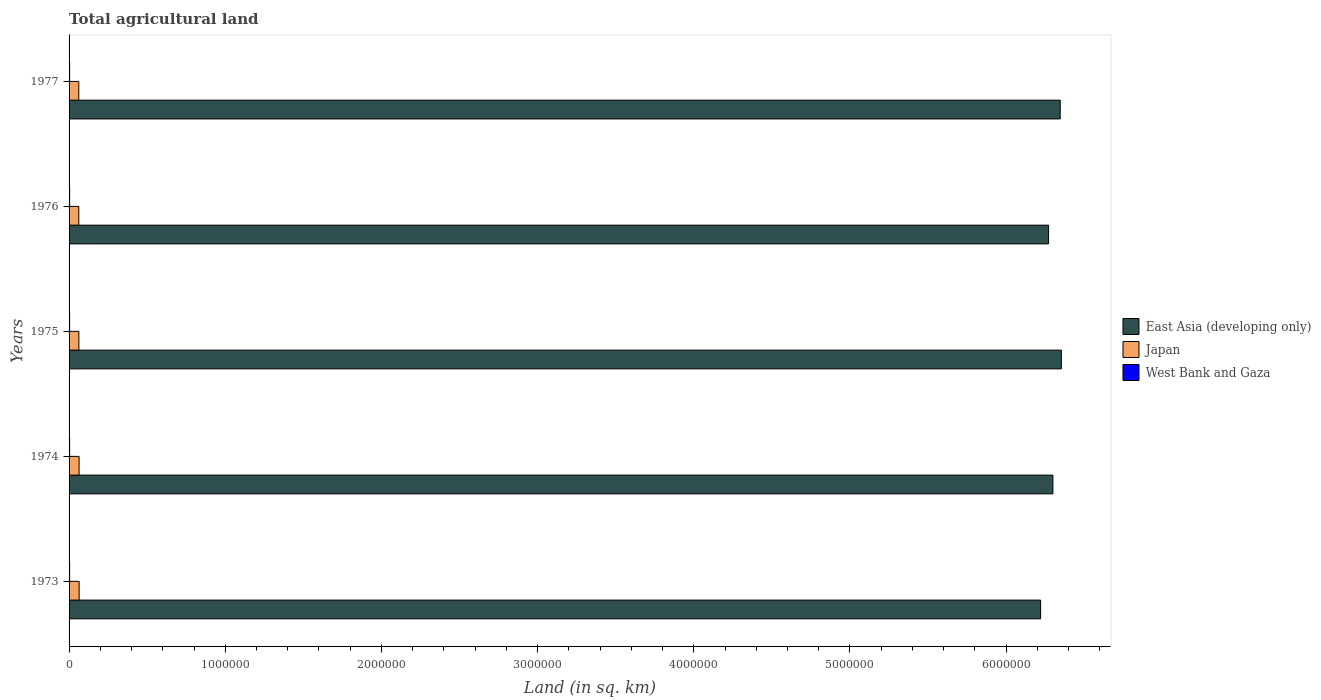How many different coloured bars are there?
Ensure brevity in your answer.  3. Are the number of bars on each tick of the Y-axis equal?
Ensure brevity in your answer.  Yes. How many bars are there on the 3rd tick from the top?
Provide a short and direct response. 3. In how many cases, is the number of bars for a given year not equal to the number of legend labels?
Keep it short and to the point. 0. What is the total agricultural land in East Asia (developing only) in 1977?
Make the answer very short. 6.35e+06. Across all years, what is the maximum total agricultural land in East Asia (developing only)?
Your answer should be very brief. 6.35e+06. Across all years, what is the minimum total agricultural land in West Bank and Gaza?
Your answer should be compact. 3680. In which year was the total agricultural land in East Asia (developing only) maximum?
Keep it short and to the point. 1975. In which year was the total agricultural land in East Asia (developing only) minimum?
Keep it short and to the point. 1973. What is the total total agricultural land in West Bank and Gaza in the graph?
Give a very brief answer. 1.85e+04. What is the difference between the total agricultural land in East Asia (developing only) in 1974 and that in 1976?
Ensure brevity in your answer.  2.77e+04. What is the difference between the total agricultural land in West Bank and Gaza in 1977 and the total agricultural land in East Asia (developing only) in 1973?
Give a very brief answer. -6.22e+06. What is the average total agricultural land in West Bank and Gaza per year?
Your answer should be very brief. 3700. In the year 1977, what is the difference between the total agricultural land in Japan and total agricultural land in West Bank and Gaza?
Offer a very short reply. 5.84e+04. In how many years, is the total agricultural land in West Bank and Gaza greater than 5400000 sq.km?
Provide a short and direct response. 0. Is the total agricultural land in West Bank and Gaza in 1973 less than that in 1976?
Ensure brevity in your answer.  Yes. What is the difference between the highest and the second highest total agricultural land in East Asia (developing only)?
Your answer should be compact. 7300. What is the difference between the highest and the lowest total agricultural land in East Asia (developing only)?
Offer a terse response. 1.33e+05. In how many years, is the total agricultural land in Japan greater than the average total agricultural land in Japan taken over all years?
Ensure brevity in your answer.  2. Is the sum of the total agricultural land in West Bank and Gaza in 1973 and 1975 greater than the maximum total agricultural land in East Asia (developing only) across all years?
Offer a very short reply. No. What does the 3rd bar from the top in 1977 represents?
Provide a short and direct response. East Asia (developing only). What does the 1st bar from the bottom in 1977 represents?
Offer a very short reply. East Asia (developing only). Is it the case that in every year, the sum of the total agricultural land in Japan and total agricultural land in West Bank and Gaza is greater than the total agricultural land in East Asia (developing only)?
Make the answer very short. No. How many bars are there?
Make the answer very short. 15. Are all the bars in the graph horizontal?
Make the answer very short. Yes. How many years are there in the graph?
Offer a very short reply. 5. Where does the legend appear in the graph?
Provide a succinct answer. Center right. What is the title of the graph?
Keep it short and to the point. Total agricultural land. What is the label or title of the X-axis?
Make the answer very short. Land (in sq. km). What is the Land (in sq. km) in East Asia (developing only) in 1973?
Make the answer very short. 6.22e+06. What is the Land (in sq. km) of Japan in 1973?
Provide a short and direct response. 6.45e+04. What is the Land (in sq. km) of West Bank and Gaza in 1973?
Keep it short and to the point. 3680. What is the Land (in sq. km) in East Asia (developing only) in 1974?
Your response must be concise. 6.30e+06. What is the Land (in sq. km) in Japan in 1974?
Ensure brevity in your answer.  6.42e+04. What is the Land (in sq. km) of West Bank and Gaza in 1974?
Your answer should be very brief. 3690. What is the Land (in sq. km) of East Asia (developing only) in 1975?
Your answer should be very brief. 6.35e+06. What is the Land (in sq. km) of Japan in 1975?
Your response must be concise. 6.27e+04. What is the Land (in sq. km) in West Bank and Gaza in 1975?
Provide a short and direct response. 3690. What is the Land (in sq. km) of East Asia (developing only) in 1976?
Your answer should be very brief. 6.27e+06. What is the Land (in sq. km) in Japan in 1976?
Offer a terse response. 6.24e+04. What is the Land (in sq. km) of West Bank and Gaza in 1976?
Give a very brief answer. 3710. What is the Land (in sq. km) in East Asia (developing only) in 1977?
Your response must be concise. 6.35e+06. What is the Land (in sq. km) in Japan in 1977?
Give a very brief answer. 6.22e+04. What is the Land (in sq. km) of West Bank and Gaza in 1977?
Keep it short and to the point. 3730. Across all years, what is the maximum Land (in sq. km) of East Asia (developing only)?
Your answer should be very brief. 6.35e+06. Across all years, what is the maximum Land (in sq. km) in Japan?
Provide a short and direct response. 6.45e+04. Across all years, what is the maximum Land (in sq. km) in West Bank and Gaza?
Your response must be concise. 3730. Across all years, what is the minimum Land (in sq. km) in East Asia (developing only)?
Your answer should be very brief. 6.22e+06. Across all years, what is the minimum Land (in sq. km) in Japan?
Your answer should be compact. 6.22e+04. Across all years, what is the minimum Land (in sq. km) in West Bank and Gaza?
Make the answer very short. 3680. What is the total Land (in sq. km) in East Asia (developing only) in the graph?
Provide a succinct answer. 3.15e+07. What is the total Land (in sq. km) in Japan in the graph?
Provide a short and direct response. 3.16e+05. What is the total Land (in sq. km) of West Bank and Gaza in the graph?
Your answer should be very brief. 1.85e+04. What is the difference between the Land (in sq. km) in East Asia (developing only) in 1973 and that in 1974?
Provide a succinct answer. -7.87e+04. What is the difference between the Land (in sq. km) of Japan in 1973 and that in 1974?
Your answer should be very brief. 320. What is the difference between the Land (in sq. km) of West Bank and Gaza in 1973 and that in 1974?
Ensure brevity in your answer.  -10. What is the difference between the Land (in sq. km) of East Asia (developing only) in 1973 and that in 1975?
Keep it short and to the point. -1.33e+05. What is the difference between the Land (in sq. km) of Japan in 1973 and that in 1975?
Ensure brevity in your answer.  1740. What is the difference between the Land (in sq. km) in West Bank and Gaza in 1973 and that in 1975?
Your response must be concise. -10. What is the difference between the Land (in sq. km) in East Asia (developing only) in 1973 and that in 1976?
Ensure brevity in your answer.  -5.10e+04. What is the difference between the Land (in sq. km) in Japan in 1973 and that in 1976?
Your answer should be compact. 2110. What is the difference between the Land (in sq. km) of East Asia (developing only) in 1973 and that in 1977?
Keep it short and to the point. -1.26e+05. What is the difference between the Land (in sq. km) of Japan in 1973 and that in 1977?
Offer a terse response. 2320. What is the difference between the Land (in sq. km) in East Asia (developing only) in 1974 and that in 1975?
Offer a terse response. -5.41e+04. What is the difference between the Land (in sq. km) of Japan in 1974 and that in 1975?
Your answer should be very brief. 1420. What is the difference between the Land (in sq. km) of East Asia (developing only) in 1974 and that in 1976?
Your response must be concise. 2.77e+04. What is the difference between the Land (in sq. km) of Japan in 1974 and that in 1976?
Offer a terse response. 1790. What is the difference between the Land (in sq. km) in West Bank and Gaza in 1974 and that in 1976?
Provide a short and direct response. -20. What is the difference between the Land (in sq. km) in East Asia (developing only) in 1974 and that in 1977?
Your answer should be very brief. -4.68e+04. What is the difference between the Land (in sq. km) of East Asia (developing only) in 1975 and that in 1976?
Provide a short and direct response. 8.18e+04. What is the difference between the Land (in sq. km) in Japan in 1975 and that in 1976?
Offer a very short reply. 370. What is the difference between the Land (in sq. km) in East Asia (developing only) in 1975 and that in 1977?
Offer a terse response. 7300. What is the difference between the Land (in sq. km) of Japan in 1975 and that in 1977?
Provide a succinct answer. 580. What is the difference between the Land (in sq. km) in West Bank and Gaza in 1975 and that in 1977?
Make the answer very short. -40. What is the difference between the Land (in sq. km) in East Asia (developing only) in 1976 and that in 1977?
Your answer should be compact. -7.45e+04. What is the difference between the Land (in sq. km) in Japan in 1976 and that in 1977?
Your response must be concise. 210. What is the difference between the Land (in sq. km) in East Asia (developing only) in 1973 and the Land (in sq. km) in Japan in 1974?
Make the answer very short. 6.16e+06. What is the difference between the Land (in sq. km) in East Asia (developing only) in 1973 and the Land (in sq. km) in West Bank and Gaza in 1974?
Offer a terse response. 6.22e+06. What is the difference between the Land (in sq. km) of Japan in 1973 and the Land (in sq. km) of West Bank and Gaza in 1974?
Your answer should be very brief. 6.08e+04. What is the difference between the Land (in sq. km) in East Asia (developing only) in 1973 and the Land (in sq. km) in Japan in 1975?
Provide a succinct answer. 6.16e+06. What is the difference between the Land (in sq. km) in East Asia (developing only) in 1973 and the Land (in sq. km) in West Bank and Gaza in 1975?
Your answer should be very brief. 6.22e+06. What is the difference between the Land (in sq. km) in Japan in 1973 and the Land (in sq. km) in West Bank and Gaza in 1975?
Provide a succinct answer. 6.08e+04. What is the difference between the Land (in sq. km) in East Asia (developing only) in 1973 and the Land (in sq. km) in Japan in 1976?
Give a very brief answer. 6.16e+06. What is the difference between the Land (in sq. km) in East Asia (developing only) in 1973 and the Land (in sq. km) in West Bank and Gaza in 1976?
Give a very brief answer. 6.22e+06. What is the difference between the Land (in sq. km) in Japan in 1973 and the Land (in sq. km) in West Bank and Gaza in 1976?
Give a very brief answer. 6.08e+04. What is the difference between the Land (in sq. km) of East Asia (developing only) in 1973 and the Land (in sq. km) of Japan in 1977?
Your answer should be compact. 6.16e+06. What is the difference between the Land (in sq. km) of East Asia (developing only) in 1973 and the Land (in sq. km) of West Bank and Gaza in 1977?
Ensure brevity in your answer.  6.22e+06. What is the difference between the Land (in sq. km) in Japan in 1973 and the Land (in sq. km) in West Bank and Gaza in 1977?
Your response must be concise. 6.07e+04. What is the difference between the Land (in sq. km) of East Asia (developing only) in 1974 and the Land (in sq. km) of Japan in 1975?
Ensure brevity in your answer.  6.24e+06. What is the difference between the Land (in sq. km) of East Asia (developing only) in 1974 and the Land (in sq. km) of West Bank and Gaza in 1975?
Your response must be concise. 6.30e+06. What is the difference between the Land (in sq. km) of Japan in 1974 and the Land (in sq. km) of West Bank and Gaza in 1975?
Your answer should be very brief. 6.05e+04. What is the difference between the Land (in sq. km) of East Asia (developing only) in 1974 and the Land (in sq. km) of Japan in 1976?
Provide a short and direct response. 6.24e+06. What is the difference between the Land (in sq. km) of East Asia (developing only) in 1974 and the Land (in sq. km) of West Bank and Gaza in 1976?
Your response must be concise. 6.30e+06. What is the difference between the Land (in sq. km) of Japan in 1974 and the Land (in sq. km) of West Bank and Gaza in 1976?
Provide a short and direct response. 6.04e+04. What is the difference between the Land (in sq. km) of East Asia (developing only) in 1974 and the Land (in sq. km) of Japan in 1977?
Offer a terse response. 6.24e+06. What is the difference between the Land (in sq. km) in East Asia (developing only) in 1974 and the Land (in sq. km) in West Bank and Gaza in 1977?
Keep it short and to the point. 6.30e+06. What is the difference between the Land (in sq. km) of Japan in 1974 and the Land (in sq. km) of West Bank and Gaza in 1977?
Provide a short and direct response. 6.04e+04. What is the difference between the Land (in sq. km) of East Asia (developing only) in 1975 and the Land (in sq. km) of Japan in 1976?
Your answer should be very brief. 6.29e+06. What is the difference between the Land (in sq. km) of East Asia (developing only) in 1975 and the Land (in sq. km) of West Bank and Gaza in 1976?
Give a very brief answer. 6.35e+06. What is the difference between the Land (in sq. km) of Japan in 1975 and the Land (in sq. km) of West Bank and Gaza in 1976?
Your response must be concise. 5.90e+04. What is the difference between the Land (in sq. km) of East Asia (developing only) in 1975 and the Land (in sq. km) of Japan in 1977?
Provide a short and direct response. 6.29e+06. What is the difference between the Land (in sq. km) of East Asia (developing only) in 1975 and the Land (in sq. km) of West Bank and Gaza in 1977?
Provide a short and direct response. 6.35e+06. What is the difference between the Land (in sq. km) of Japan in 1975 and the Land (in sq. km) of West Bank and Gaza in 1977?
Ensure brevity in your answer.  5.90e+04. What is the difference between the Land (in sq. km) of East Asia (developing only) in 1976 and the Land (in sq. km) of Japan in 1977?
Offer a very short reply. 6.21e+06. What is the difference between the Land (in sq. km) of East Asia (developing only) in 1976 and the Land (in sq. km) of West Bank and Gaza in 1977?
Give a very brief answer. 6.27e+06. What is the difference between the Land (in sq. km) in Japan in 1976 and the Land (in sq. km) in West Bank and Gaza in 1977?
Provide a succinct answer. 5.86e+04. What is the average Land (in sq. km) in East Asia (developing only) per year?
Make the answer very short. 6.30e+06. What is the average Land (in sq. km) of Japan per year?
Provide a short and direct response. 6.32e+04. What is the average Land (in sq. km) in West Bank and Gaza per year?
Make the answer very short. 3700. In the year 1973, what is the difference between the Land (in sq. km) in East Asia (developing only) and Land (in sq. km) in Japan?
Give a very brief answer. 6.16e+06. In the year 1973, what is the difference between the Land (in sq. km) of East Asia (developing only) and Land (in sq. km) of West Bank and Gaza?
Ensure brevity in your answer.  6.22e+06. In the year 1973, what is the difference between the Land (in sq. km) in Japan and Land (in sq. km) in West Bank and Gaza?
Keep it short and to the point. 6.08e+04. In the year 1974, what is the difference between the Land (in sq. km) of East Asia (developing only) and Land (in sq. km) of Japan?
Your answer should be compact. 6.24e+06. In the year 1974, what is the difference between the Land (in sq. km) of East Asia (developing only) and Land (in sq. km) of West Bank and Gaza?
Give a very brief answer. 6.30e+06. In the year 1974, what is the difference between the Land (in sq. km) of Japan and Land (in sq. km) of West Bank and Gaza?
Offer a very short reply. 6.05e+04. In the year 1975, what is the difference between the Land (in sq. km) in East Asia (developing only) and Land (in sq. km) in Japan?
Give a very brief answer. 6.29e+06. In the year 1975, what is the difference between the Land (in sq. km) of East Asia (developing only) and Land (in sq. km) of West Bank and Gaza?
Ensure brevity in your answer.  6.35e+06. In the year 1975, what is the difference between the Land (in sq. km) of Japan and Land (in sq. km) of West Bank and Gaza?
Keep it short and to the point. 5.90e+04. In the year 1976, what is the difference between the Land (in sq. km) of East Asia (developing only) and Land (in sq. km) of Japan?
Keep it short and to the point. 6.21e+06. In the year 1976, what is the difference between the Land (in sq. km) in East Asia (developing only) and Land (in sq. km) in West Bank and Gaza?
Provide a succinct answer. 6.27e+06. In the year 1976, what is the difference between the Land (in sq. km) in Japan and Land (in sq. km) in West Bank and Gaza?
Offer a terse response. 5.86e+04. In the year 1977, what is the difference between the Land (in sq. km) in East Asia (developing only) and Land (in sq. km) in Japan?
Provide a succinct answer. 6.28e+06. In the year 1977, what is the difference between the Land (in sq. km) of East Asia (developing only) and Land (in sq. km) of West Bank and Gaza?
Your response must be concise. 6.34e+06. In the year 1977, what is the difference between the Land (in sq. km) of Japan and Land (in sq. km) of West Bank and Gaza?
Offer a very short reply. 5.84e+04. What is the ratio of the Land (in sq. km) in East Asia (developing only) in 1973 to that in 1974?
Offer a terse response. 0.99. What is the ratio of the Land (in sq. km) in Japan in 1973 to that in 1974?
Your answer should be compact. 1. What is the ratio of the Land (in sq. km) in West Bank and Gaza in 1973 to that in 1974?
Your answer should be compact. 1. What is the ratio of the Land (in sq. km) of East Asia (developing only) in 1973 to that in 1975?
Give a very brief answer. 0.98. What is the ratio of the Land (in sq. km) of Japan in 1973 to that in 1975?
Provide a short and direct response. 1.03. What is the ratio of the Land (in sq. km) of Japan in 1973 to that in 1976?
Offer a terse response. 1.03. What is the ratio of the Land (in sq. km) of West Bank and Gaza in 1973 to that in 1976?
Ensure brevity in your answer.  0.99. What is the ratio of the Land (in sq. km) of East Asia (developing only) in 1973 to that in 1977?
Keep it short and to the point. 0.98. What is the ratio of the Land (in sq. km) of Japan in 1973 to that in 1977?
Your answer should be very brief. 1.04. What is the ratio of the Land (in sq. km) in West Bank and Gaza in 1973 to that in 1977?
Ensure brevity in your answer.  0.99. What is the ratio of the Land (in sq. km) in Japan in 1974 to that in 1975?
Provide a short and direct response. 1.02. What is the ratio of the Land (in sq. km) in East Asia (developing only) in 1974 to that in 1976?
Keep it short and to the point. 1. What is the ratio of the Land (in sq. km) of Japan in 1974 to that in 1976?
Ensure brevity in your answer.  1.03. What is the ratio of the Land (in sq. km) in West Bank and Gaza in 1974 to that in 1976?
Make the answer very short. 0.99. What is the ratio of the Land (in sq. km) in Japan in 1974 to that in 1977?
Your answer should be very brief. 1.03. What is the ratio of the Land (in sq. km) of West Bank and Gaza in 1974 to that in 1977?
Make the answer very short. 0.99. What is the ratio of the Land (in sq. km) in East Asia (developing only) in 1975 to that in 1976?
Your answer should be compact. 1.01. What is the ratio of the Land (in sq. km) of Japan in 1975 to that in 1976?
Ensure brevity in your answer.  1.01. What is the ratio of the Land (in sq. km) in West Bank and Gaza in 1975 to that in 1976?
Keep it short and to the point. 0.99. What is the ratio of the Land (in sq. km) in Japan in 1975 to that in 1977?
Make the answer very short. 1.01. What is the ratio of the Land (in sq. km) in West Bank and Gaza in 1975 to that in 1977?
Keep it short and to the point. 0.99. What is the ratio of the Land (in sq. km) in East Asia (developing only) in 1976 to that in 1977?
Provide a short and direct response. 0.99. What is the difference between the highest and the second highest Land (in sq. km) of East Asia (developing only)?
Your answer should be compact. 7300. What is the difference between the highest and the second highest Land (in sq. km) of Japan?
Your answer should be compact. 320. What is the difference between the highest and the second highest Land (in sq. km) in West Bank and Gaza?
Your answer should be compact. 20. What is the difference between the highest and the lowest Land (in sq. km) in East Asia (developing only)?
Provide a succinct answer. 1.33e+05. What is the difference between the highest and the lowest Land (in sq. km) in Japan?
Give a very brief answer. 2320. 